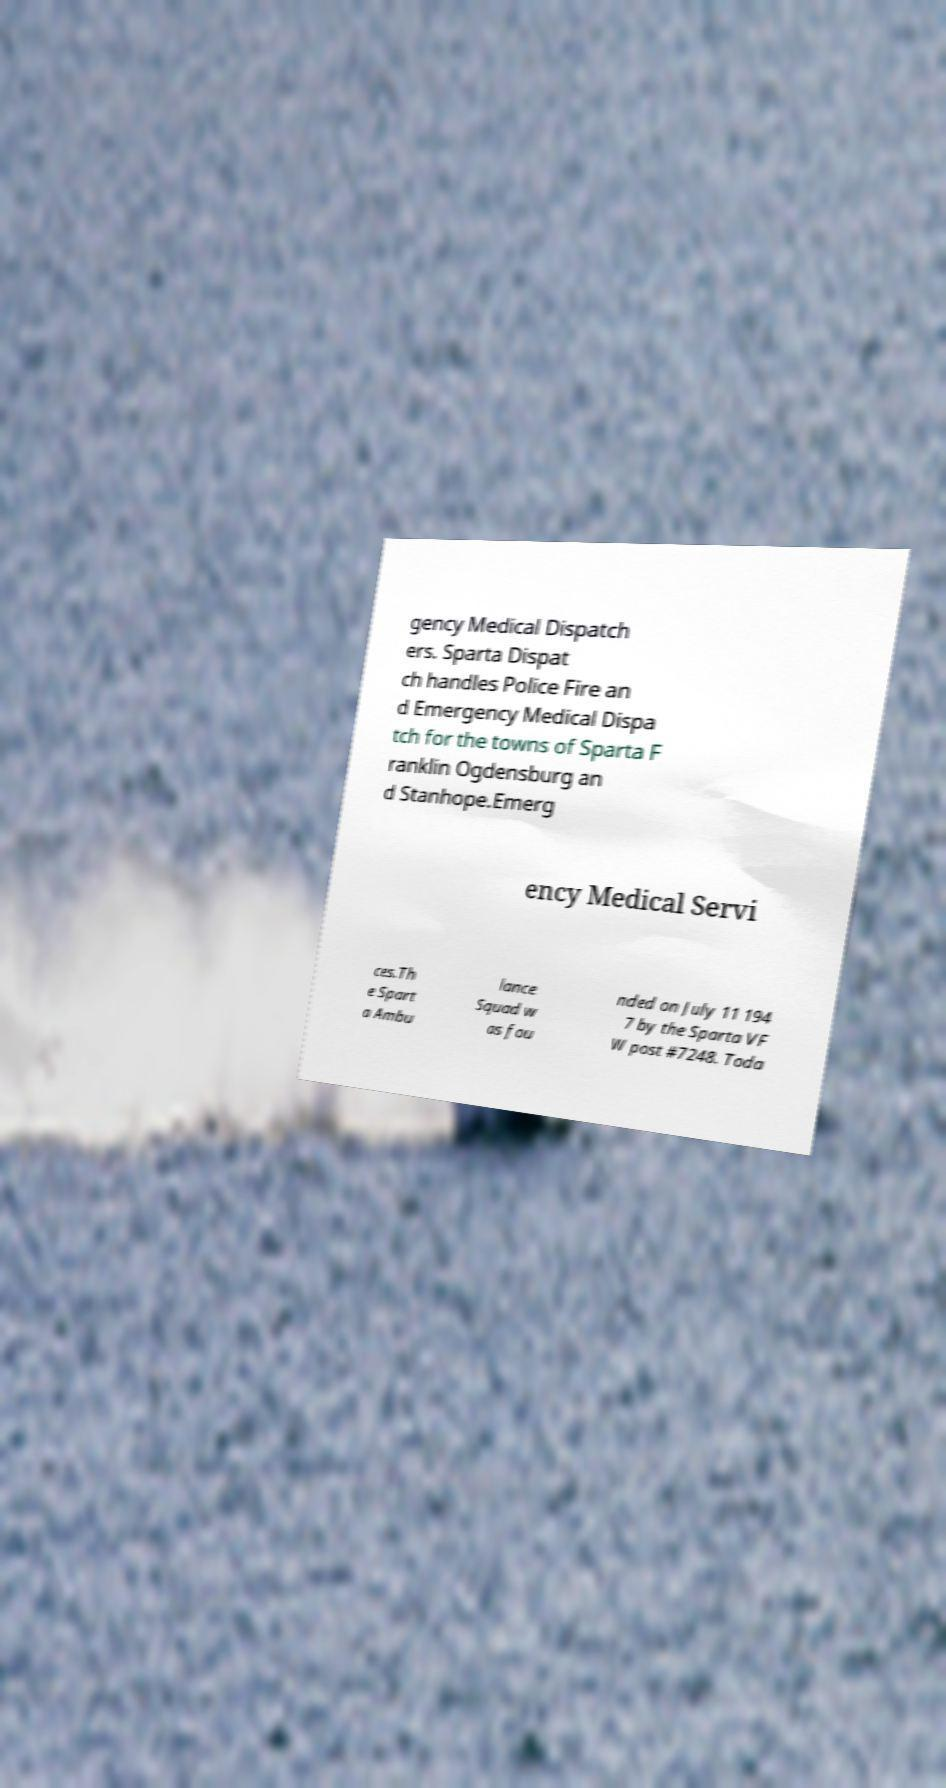Could you assist in decoding the text presented in this image and type it out clearly? gency Medical Dispatch ers. Sparta Dispat ch handles Police Fire an d Emergency Medical Dispa tch for the towns of Sparta F ranklin Ogdensburg an d Stanhope.Emerg ency Medical Servi ces.Th e Spart a Ambu lance Squad w as fou nded on July 11 194 7 by the Sparta VF W post #7248. Toda 